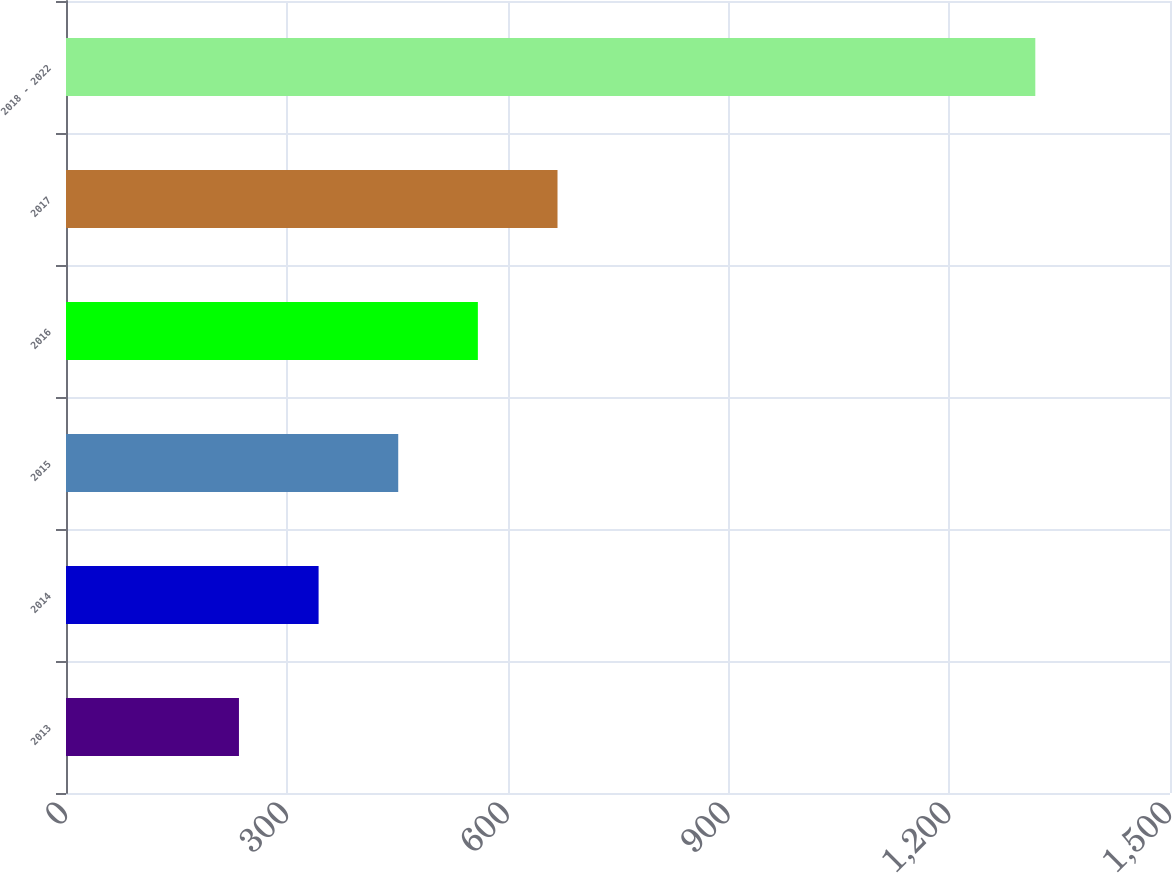<chart> <loc_0><loc_0><loc_500><loc_500><bar_chart><fcel>2013<fcel>2014<fcel>2015<fcel>2016<fcel>2017<fcel>2018 - 2022<nl><fcel>235<fcel>343.2<fcel>451.4<fcel>559.6<fcel>667.8<fcel>1317<nl></chart> 